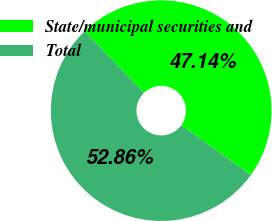Convert chart. <chart><loc_0><loc_0><loc_500><loc_500><pie_chart><fcel>State/municipal securities and<fcel>Total<nl><fcel>47.14%<fcel>52.86%<nl></chart> 